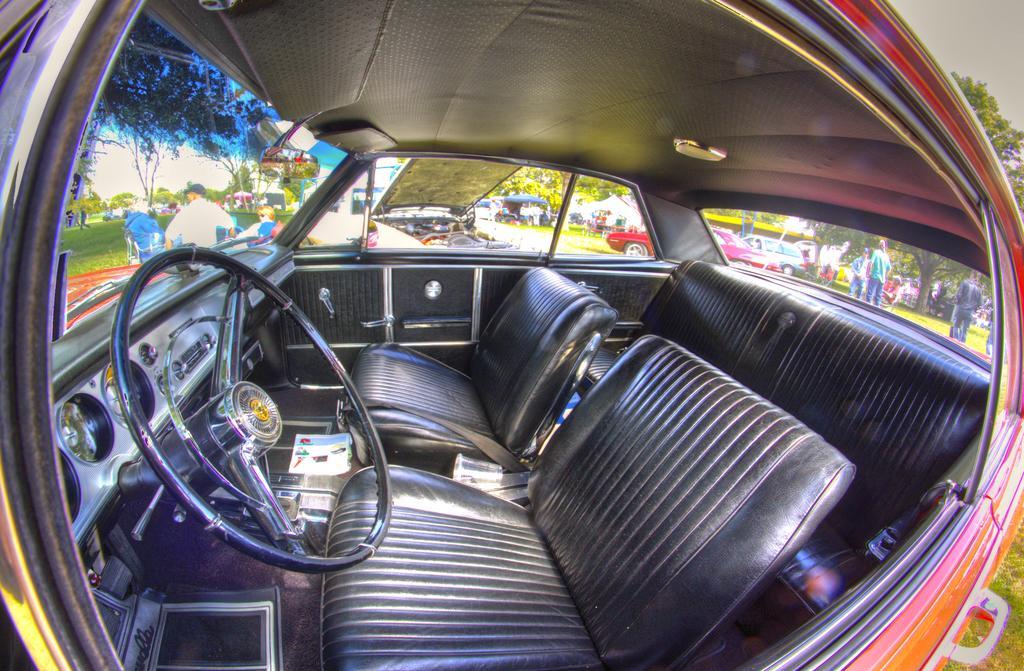Can you describe this image briefly? In the foreground of this picture, there is a vehicle in which we can see steering, seats, door, mirror, and the light. In the background, there are tents, vehicles, chairs, persons, grass, trees, and the sky. 